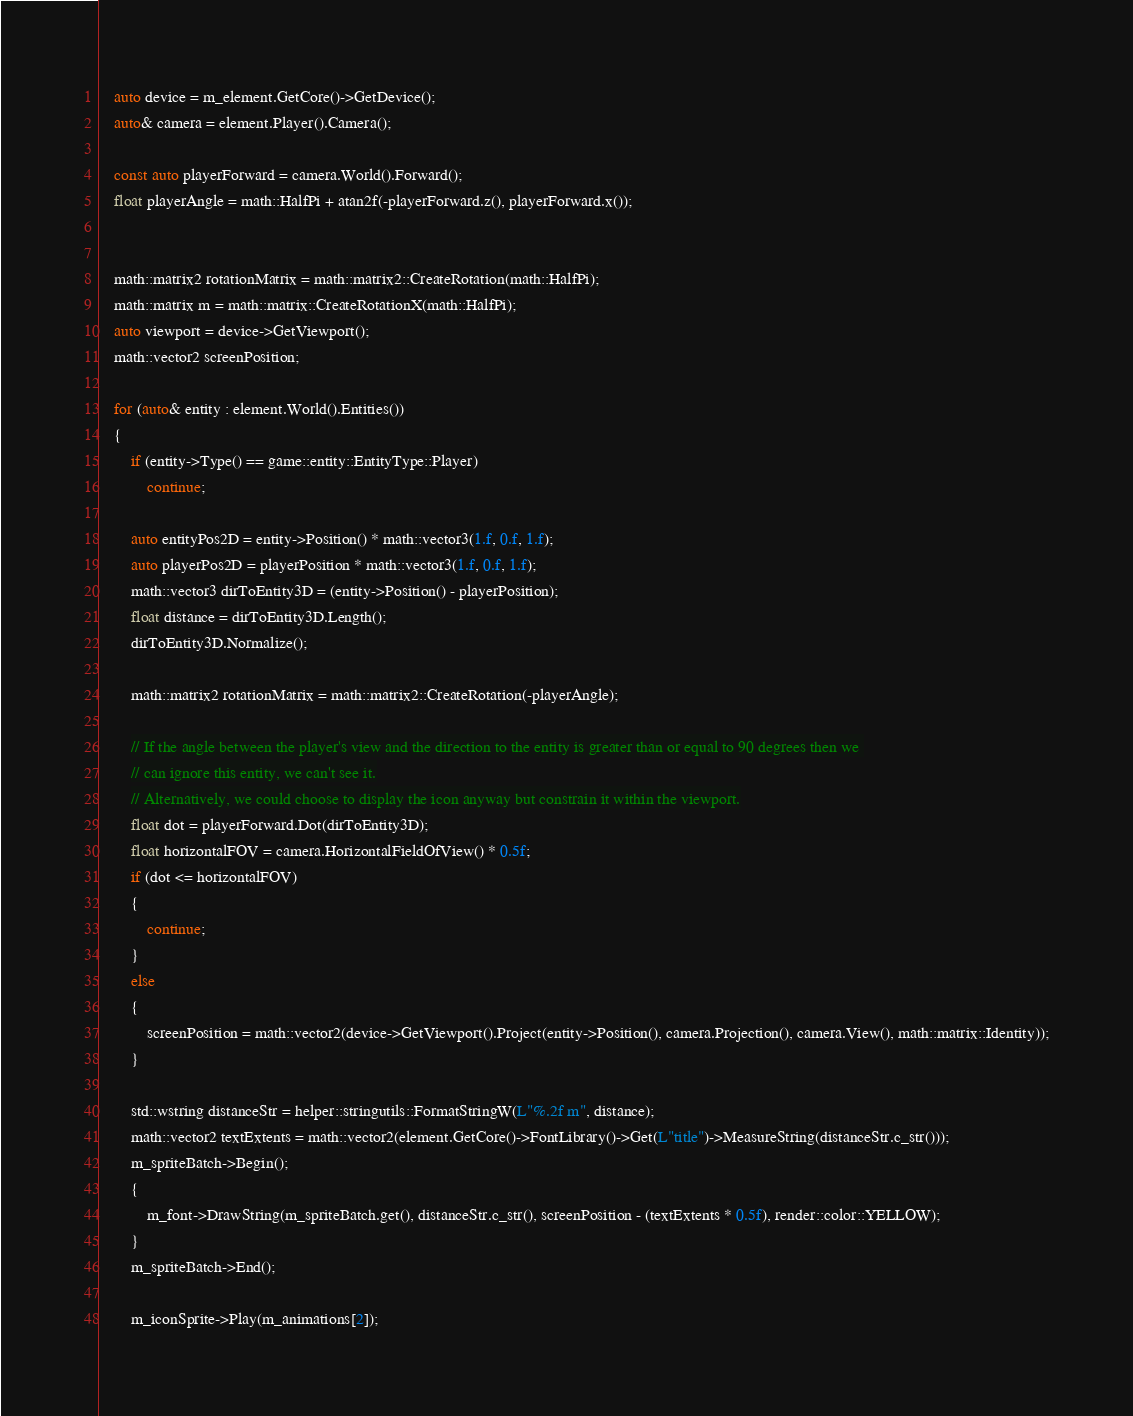<code> <loc_0><loc_0><loc_500><loc_500><_C++_>
	auto device = m_element.GetCore()->GetDevice();
	auto& camera = element.Player().Camera();

	const auto playerForward = camera.World().Forward();
	float playerAngle = math::HalfPi + atan2f(-playerForward.z(), playerForward.x());
	
	
	math::matrix2 rotationMatrix = math::matrix2::CreateRotation(math::HalfPi);
	math::matrix m = math::matrix::CreateRotationX(math::HalfPi);
	auto viewport = device->GetViewport();
	math::vector2 screenPosition;

	for (auto& entity : element.World().Entities())
	{
		if (entity->Type() == game::entity::EntityType::Player)
			continue;

		auto entityPos2D = entity->Position() * math::vector3(1.f, 0.f, 1.f);
		auto playerPos2D = playerPosition * math::vector3(1.f, 0.f, 1.f);
		math::vector3 dirToEntity3D = (entity->Position() - playerPosition);
		float distance = dirToEntity3D.Length();
		dirToEntity3D.Normalize();

		math::matrix2 rotationMatrix = math::matrix2::CreateRotation(-playerAngle);

		// If the angle between the player's view and the direction to the entity is greater than or equal to 90 degrees then we 
		// can ignore this entity, we can't see it.
		// Alternatively, we could choose to display the icon anyway but constrain it within the viewport.
		float dot = playerForward.Dot(dirToEntity3D);
		float horizontalFOV = camera.HorizontalFieldOfView() * 0.5f;
		if (dot <= horizontalFOV)
		{
			continue;
		}
		else
		{
			screenPosition = math::vector2(device->GetViewport().Project(entity->Position(), camera.Projection(), camera.View(), math::matrix::Identity));
		}

		std::wstring distanceStr = helper::stringutils::FormatStringW(L"%.2f m", distance);
		math::vector2 textExtents = math::vector2(element.GetCore()->FontLibrary()->Get(L"title")->MeasureString(distanceStr.c_str()));
		m_spriteBatch->Begin();
		{
			m_font->DrawString(m_spriteBatch.get(), distanceStr.c_str(), screenPosition - (textExtents * 0.5f), render::color::YELLOW);
		}
		m_spriteBatch->End();
		
		m_iconSprite->Play(m_animations[2]);
</code> 